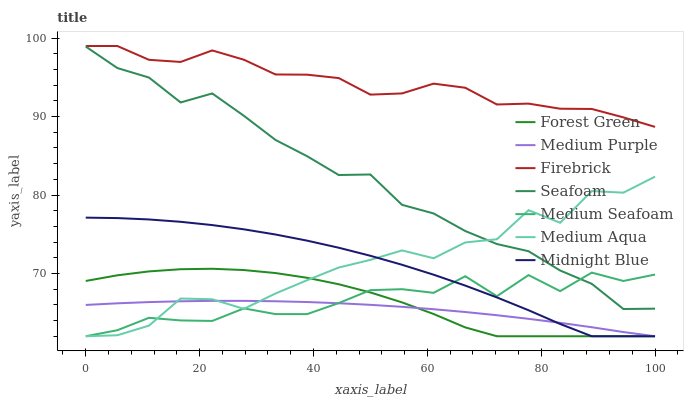Does Seafoam have the minimum area under the curve?
Answer yes or no. No. Does Seafoam have the maximum area under the curve?
Answer yes or no. No. Is Firebrick the smoothest?
Answer yes or no. No. Is Firebrick the roughest?
Answer yes or no. No. Does Seafoam have the lowest value?
Answer yes or no. No. Does Seafoam have the highest value?
Answer yes or no. No. Is Medium Aqua less than Firebrick?
Answer yes or no. Yes. Is Seafoam greater than Medium Purple?
Answer yes or no. Yes. Does Medium Aqua intersect Firebrick?
Answer yes or no. No. 